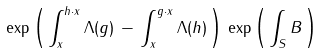Convert formula to latex. <formula><loc_0><loc_0><loc_500><loc_500>\exp \left ( \, \int _ { x } ^ { h \cdot x } \Lambda ( g ) \, - \, \int _ { x } ^ { g \cdot x } \Lambda ( h ) \, \right ) \, \exp \left ( \, \int _ { S } B \, \right )</formula> 